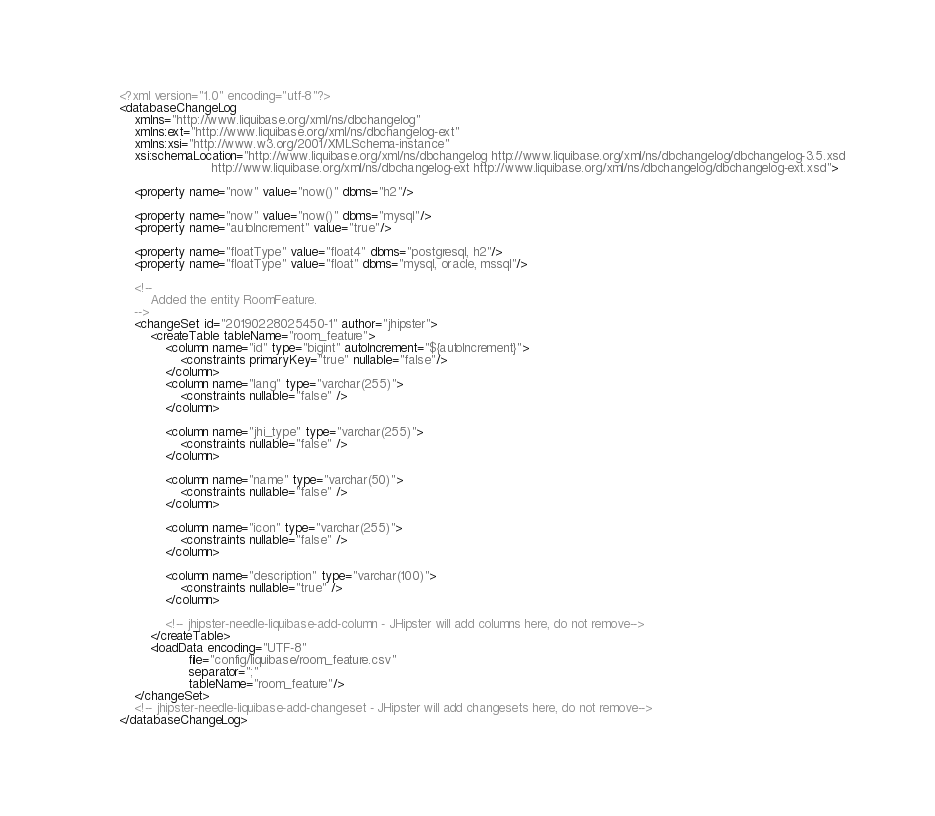Convert code to text. <code><loc_0><loc_0><loc_500><loc_500><_XML_><?xml version="1.0" encoding="utf-8"?>
<databaseChangeLog
    xmlns="http://www.liquibase.org/xml/ns/dbchangelog"
    xmlns:ext="http://www.liquibase.org/xml/ns/dbchangelog-ext"
    xmlns:xsi="http://www.w3.org/2001/XMLSchema-instance"
    xsi:schemaLocation="http://www.liquibase.org/xml/ns/dbchangelog http://www.liquibase.org/xml/ns/dbchangelog/dbchangelog-3.5.xsd
                        http://www.liquibase.org/xml/ns/dbchangelog-ext http://www.liquibase.org/xml/ns/dbchangelog/dbchangelog-ext.xsd">

    <property name="now" value="now()" dbms="h2"/>
    
    <property name="now" value="now()" dbms="mysql"/>
    <property name="autoIncrement" value="true"/>

    <property name="floatType" value="float4" dbms="postgresql, h2"/>
    <property name="floatType" value="float" dbms="mysql, oracle, mssql"/>

    <!--
        Added the entity RoomFeature.
    -->
    <changeSet id="20190228025450-1" author="jhipster">
        <createTable tableName="room_feature">
            <column name="id" type="bigint" autoIncrement="${autoIncrement}">
                <constraints primaryKey="true" nullable="false"/>
            </column>
            <column name="lang" type="varchar(255)">
                <constraints nullable="false" />
            </column>

            <column name="jhi_type" type="varchar(255)">
                <constraints nullable="false" />
            </column>

            <column name="name" type="varchar(50)">
                <constraints nullable="false" />
            </column>

            <column name="icon" type="varchar(255)">
                <constraints nullable="false" />
            </column>

            <column name="description" type="varchar(100)">
                <constraints nullable="true" />
            </column>

            <!-- jhipster-needle-liquibase-add-column - JHipster will add columns here, do not remove-->
        </createTable>
        <loadData encoding="UTF-8"
                  file="config/liquibase/room_feature.csv"
                  separator=";"
                  tableName="room_feature"/>
    </changeSet>
    <!-- jhipster-needle-liquibase-add-changeset - JHipster will add changesets here, do not remove-->
</databaseChangeLog>
</code> 